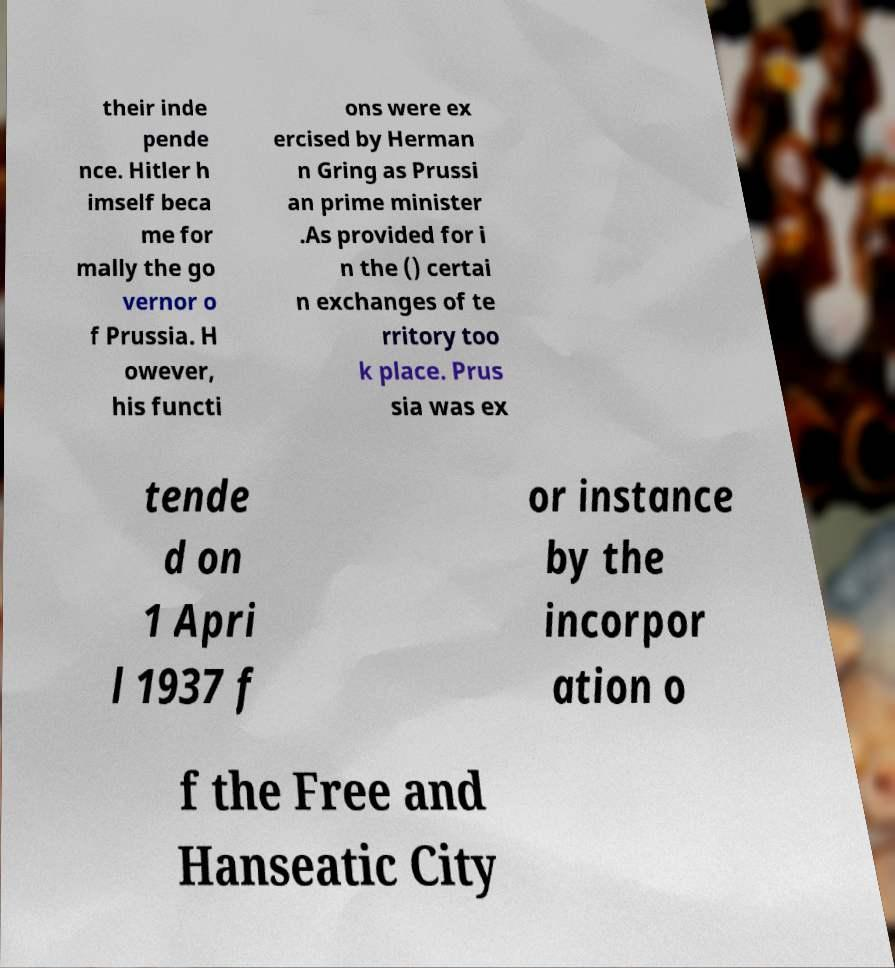I need the written content from this picture converted into text. Can you do that? their inde pende nce. Hitler h imself beca me for mally the go vernor o f Prussia. H owever, his functi ons were ex ercised by Herman n Gring as Prussi an prime minister .As provided for i n the () certai n exchanges of te rritory too k place. Prus sia was ex tende d on 1 Apri l 1937 f or instance by the incorpor ation o f the Free and Hanseatic City 